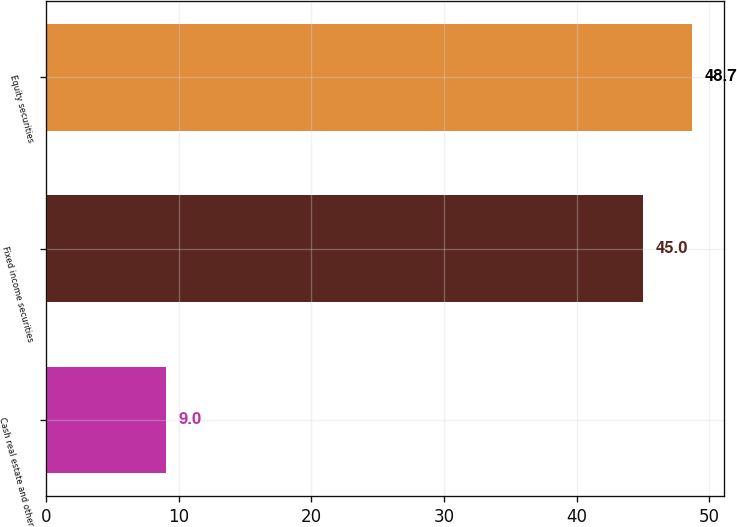Convert chart. <chart><loc_0><loc_0><loc_500><loc_500><bar_chart><fcel>Cash real estate and other<fcel>Fixed income securities<fcel>Equity securities<nl><fcel>9<fcel>45<fcel>48.7<nl></chart> 